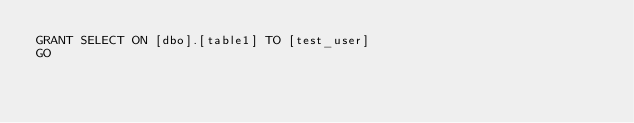Convert code to text. <code><loc_0><loc_0><loc_500><loc_500><_SQL_>GRANT SELECT ON [dbo].[table1] TO [test_user]
GO</code> 